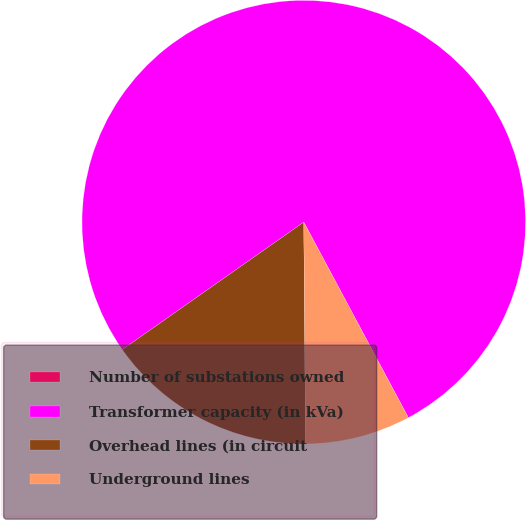Convert chart. <chart><loc_0><loc_0><loc_500><loc_500><pie_chart><fcel>Number of substations owned<fcel>Transformer capacity (in kVa)<fcel>Overhead lines (in circuit<fcel>Underground lines<nl><fcel>0.0%<fcel>76.92%<fcel>15.38%<fcel>7.69%<nl></chart> 